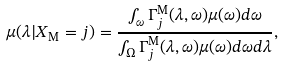<formula> <loc_0><loc_0><loc_500><loc_500>\mu ( \lambda | X _ { \text {M} } = j ) = \frac { \int _ { \omega } \Gamma ^ { \text {M} } _ { j } ( \lambda , \omega ) \mu ( \omega ) d \omega } { \int _ { \Omega } \Gamma ^ { \text {M} } _ { j } ( \lambda , \omega ) \mu ( \omega ) d \omega d \lambda } ,</formula> 